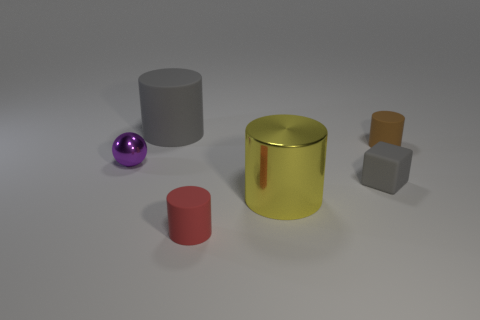What number of other rubber things are the same shape as the large gray matte thing?
Your answer should be very brief. 2. What number of gray objects have the same size as the red matte thing?
Your answer should be compact. 1. There is another red object that is the same shape as the big matte thing; what material is it?
Offer a very short reply. Rubber. There is a large object that is behind the big shiny cylinder; what color is it?
Your response must be concise. Gray. Is the number of tiny things behind the small shiny ball greater than the number of large purple cylinders?
Provide a succinct answer. Yes. The small metal thing has what color?
Your answer should be compact. Purple. What shape is the metal object that is on the left side of the large thing in front of the gray rubber object that is behind the purple shiny ball?
Offer a terse response. Sphere. What material is the object that is both to the right of the purple shiny sphere and on the left side of the tiny red object?
Provide a short and direct response. Rubber. What is the shape of the large object that is behind the small sphere in front of the big gray rubber cylinder?
Ensure brevity in your answer.  Cylinder. Is there anything else of the same color as the metallic cylinder?
Your answer should be very brief. No. 